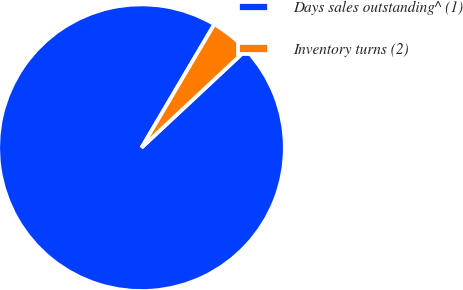<chart> <loc_0><loc_0><loc_500><loc_500><pie_chart><fcel>Days sales outstanding^ (1)<fcel>Inventory turns (2)<nl><fcel>95.45%<fcel>4.55%<nl></chart> 